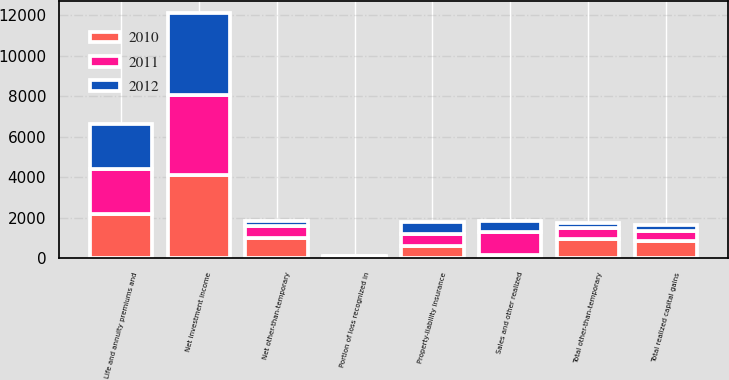<chart> <loc_0><loc_0><loc_500><loc_500><stacked_bar_chart><ecel><fcel>Property-liability insurance<fcel>Life and annuity premiums and<fcel>Net investment income<fcel>Total other-than-temporary<fcel>Portion of loss recognized in<fcel>Net other-than-temporary<fcel>Sales and other realized<fcel>Total realized capital gains<nl><fcel>2012<fcel>596<fcel>2241<fcel>4010<fcel>239<fcel>6<fcel>233<fcel>560<fcel>327<nl><fcel>2011<fcel>596<fcel>2238<fcel>3971<fcel>563<fcel>33<fcel>596<fcel>1099<fcel>503<nl><fcel>2010<fcel>596<fcel>2168<fcel>4102<fcel>937<fcel>64<fcel>1001<fcel>174<fcel>827<nl></chart> 